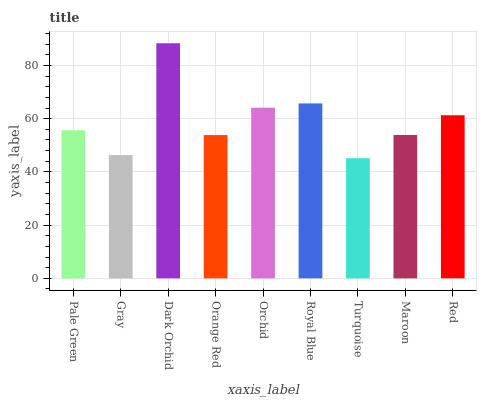Is Turquoise the minimum?
Answer yes or no. Yes. Is Dark Orchid the maximum?
Answer yes or no. Yes. Is Gray the minimum?
Answer yes or no. No. Is Gray the maximum?
Answer yes or no. No. Is Pale Green greater than Gray?
Answer yes or no. Yes. Is Gray less than Pale Green?
Answer yes or no. Yes. Is Gray greater than Pale Green?
Answer yes or no. No. Is Pale Green less than Gray?
Answer yes or no. No. Is Pale Green the high median?
Answer yes or no. Yes. Is Pale Green the low median?
Answer yes or no. Yes. Is Gray the high median?
Answer yes or no. No. Is Red the low median?
Answer yes or no. No. 